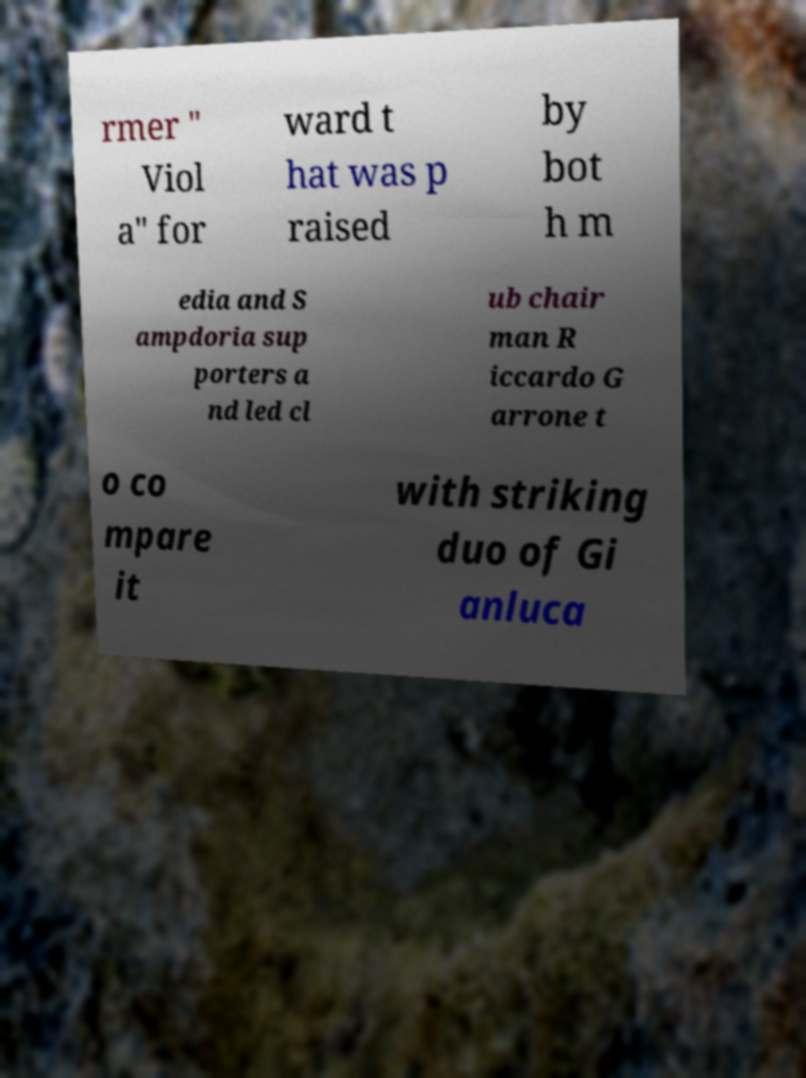Could you extract and type out the text from this image? rmer " Viol a" for ward t hat was p raised by bot h m edia and S ampdoria sup porters a nd led cl ub chair man R iccardo G arrone t o co mpare it with striking duo of Gi anluca 